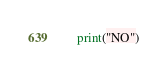Convert code to text. <code><loc_0><loc_0><loc_500><loc_500><_Python_>    print("NO")</code> 